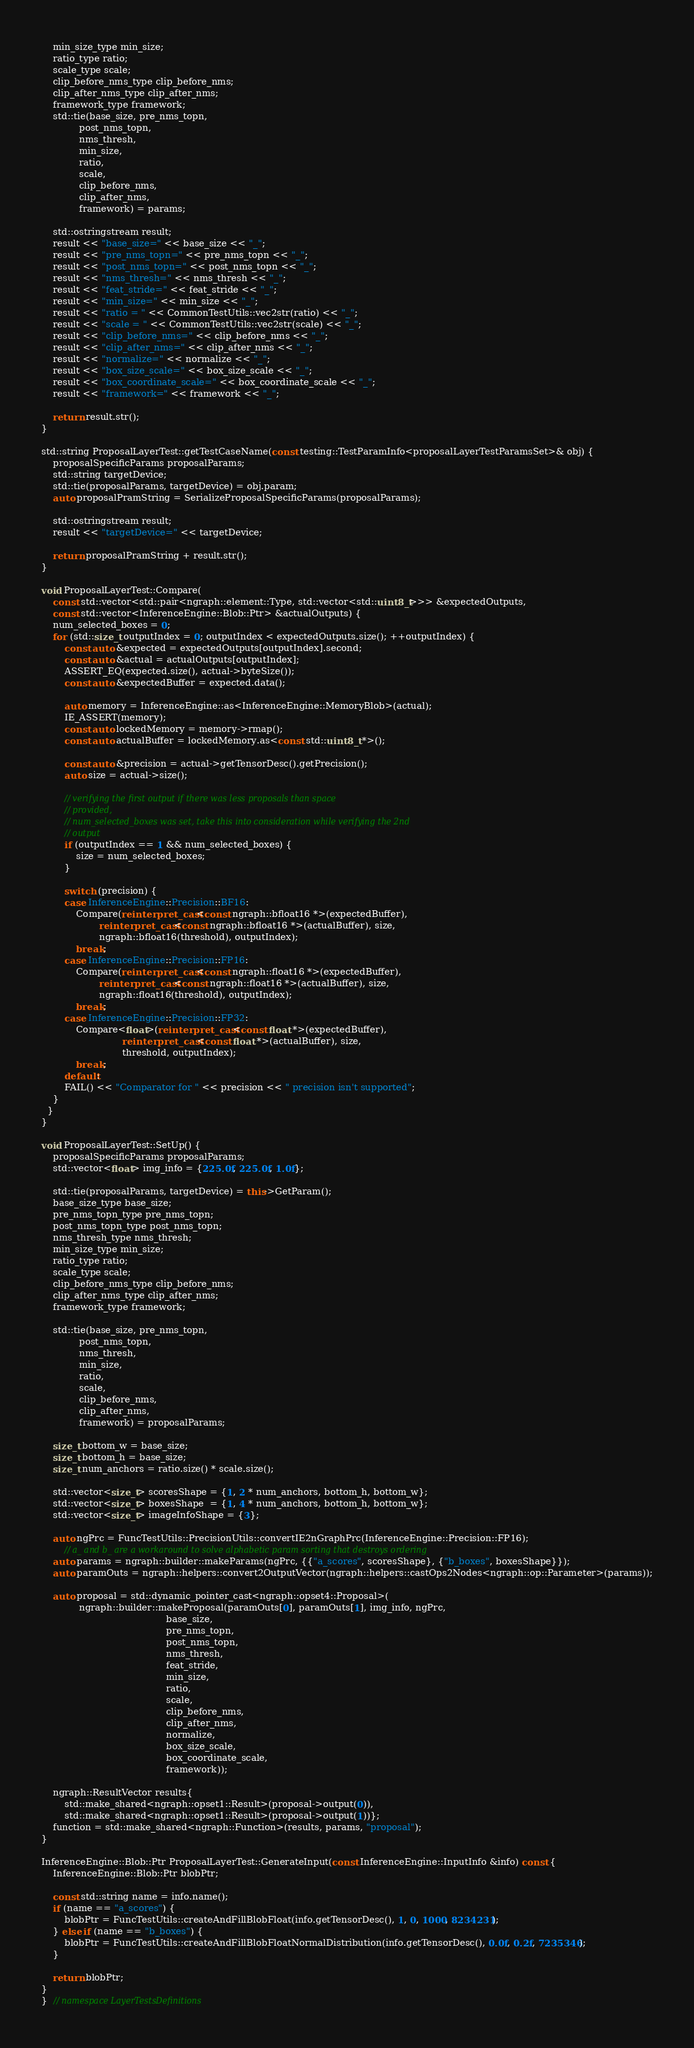Convert code to text. <code><loc_0><loc_0><loc_500><loc_500><_C++_>    min_size_type min_size;
    ratio_type ratio;
    scale_type scale;
    clip_before_nms_type clip_before_nms;
    clip_after_nms_type clip_after_nms;
    framework_type framework;
    std::tie(base_size, pre_nms_topn,
             post_nms_topn,
             nms_thresh,
             min_size,
             ratio,
             scale,
             clip_before_nms,
             clip_after_nms,
             framework) = params;

    std::ostringstream result;
    result << "base_size=" << base_size << "_";
    result << "pre_nms_topn=" << pre_nms_topn << "_";
    result << "post_nms_topn=" << post_nms_topn << "_";
    result << "nms_thresh=" << nms_thresh << "_";
    result << "feat_stride=" << feat_stride << "_";
    result << "min_size=" << min_size << "_";
    result << "ratio = " << CommonTestUtils::vec2str(ratio) << "_";
    result << "scale = " << CommonTestUtils::vec2str(scale) << "_";
    result << "clip_before_nms=" << clip_before_nms << "_";
    result << "clip_after_nms=" << clip_after_nms << "_";
    result << "normalize=" << normalize << "_";
    result << "box_size_scale=" << box_size_scale << "_";
    result << "box_coordinate_scale=" << box_coordinate_scale << "_";
    result << "framework=" << framework << "_";

    return result.str();
}

std::string ProposalLayerTest::getTestCaseName(const testing::TestParamInfo<proposalLayerTestParamsSet>& obj) {
    proposalSpecificParams proposalParams;
    std::string targetDevice;
    std::tie(proposalParams, targetDevice) = obj.param;
    auto proposalPramString = SerializeProposalSpecificParams(proposalParams);

    std::ostringstream result;
    result << "targetDevice=" << targetDevice;

    return proposalPramString + result.str();
}

void ProposalLayerTest::Compare(
    const std::vector<std::pair<ngraph::element::Type, std::vector<std::uint8_t>>> &expectedOutputs,
    const std::vector<InferenceEngine::Blob::Ptr> &actualOutputs) {
    num_selected_boxes = 0;
    for (std::size_t outputIndex = 0; outputIndex < expectedOutputs.size(); ++outputIndex) {
        const auto &expected = expectedOutputs[outputIndex].second;
        const auto &actual = actualOutputs[outputIndex];
        ASSERT_EQ(expected.size(), actual->byteSize());
        const auto &expectedBuffer = expected.data();

        auto memory = InferenceEngine::as<InferenceEngine::MemoryBlob>(actual);
        IE_ASSERT(memory);
        const auto lockedMemory = memory->rmap();
        const auto actualBuffer = lockedMemory.as<const std::uint8_t *>();

        const auto &precision = actual->getTensorDesc().getPrecision();
        auto size = actual->size();

        // verifying the first output if there was less proposals than space
        // provided,
        // num_selected_boxes was set, take this into consideration while verifying the 2nd
        // output
        if (outputIndex == 1 && num_selected_boxes) {
            size = num_selected_boxes;
        }

        switch (precision) {
        case InferenceEngine::Precision::BF16:
            Compare(reinterpret_cast<const ngraph::bfloat16 *>(expectedBuffer),
                    reinterpret_cast<const ngraph::bfloat16 *>(actualBuffer), size,
                    ngraph::bfloat16(threshold), outputIndex);
            break;
        case InferenceEngine::Precision::FP16:
            Compare(reinterpret_cast<const ngraph::float16 *>(expectedBuffer),
                    reinterpret_cast<const ngraph::float16 *>(actualBuffer), size,
                    ngraph::float16(threshold), outputIndex);
            break;
        case InferenceEngine::Precision::FP32:
            Compare<float>(reinterpret_cast<const float *>(expectedBuffer),
                            reinterpret_cast<const float *>(actualBuffer), size,
                            threshold, outputIndex);
            break;
        default:
        FAIL() << "Comparator for " << precision << " precision isn't supported";
    }
  }
}

void ProposalLayerTest::SetUp() {
    proposalSpecificParams proposalParams;
    std::vector<float> img_info = {225.0f, 225.0f, 1.0f};

    std::tie(proposalParams, targetDevice) = this->GetParam();
    base_size_type base_size;
    pre_nms_topn_type pre_nms_topn;
    post_nms_topn_type post_nms_topn;
    nms_thresh_type nms_thresh;
    min_size_type min_size;
    ratio_type ratio;
    scale_type scale;
    clip_before_nms_type clip_before_nms;
    clip_after_nms_type clip_after_nms;
    framework_type framework;

    std::tie(base_size, pre_nms_topn,
             post_nms_topn,
             nms_thresh,
             min_size,
             ratio,
             scale,
             clip_before_nms,
             clip_after_nms,
             framework) = proposalParams;

    size_t bottom_w = base_size;
    size_t bottom_h = base_size;
    size_t num_anchors = ratio.size() * scale.size();

    std::vector<size_t> scoresShape = {1, 2 * num_anchors, bottom_h, bottom_w};
    std::vector<size_t> boxesShape  = {1, 4 * num_anchors, bottom_h, bottom_w};
    std::vector<size_t> imageInfoShape = {3};

    auto ngPrc = FuncTestUtils::PrecisionUtils::convertIE2nGraphPrc(InferenceEngine::Precision::FP16);
        // a_ and b_ are a workaround to solve alphabetic param sorting that destroys ordering
    auto params = ngraph::builder::makeParams(ngPrc, {{"a_scores", scoresShape}, {"b_boxes", boxesShape}});
    auto paramOuts = ngraph::helpers::convert2OutputVector(ngraph::helpers::castOps2Nodes<ngraph::op::Parameter>(params));

    auto proposal = std::dynamic_pointer_cast<ngraph::opset4::Proposal>(
             ngraph::builder::makeProposal(paramOuts[0], paramOuts[1], img_info, ngPrc,
                                           base_size,
                                           pre_nms_topn,
                                           post_nms_topn,
                                           nms_thresh,
                                           feat_stride,
                                           min_size,
                                           ratio,
                                           scale,
                                           clip_before_nms,
                                           clip_after_nms,
                                           normalize,
                                           box_size_scale,
                                           box_coordinate_scale,
                                           framework));

    ngraph::ResultVector results{
        std::make_shared<ngraph::opset1::Result>(proposal->output(0)),
        std::make_shared<ngraph::opset1::Result>(proposal->output(1))};
    function = std::make_shared<ngraph::Function>(results, params, "proposal");
}

InferenceEngine::Blob::Ptr ProposalLayerTest::GenerateInput(const InferenceEngine::InputInfo &info) const {
    InferenceEngine::Blob::Ptr blobPtr;

    const std::string name = info.name();
    if (name == "a_scores") {
        blobPtr = FuncTestUtils::createAndFillBlobFloat(info.getTensorDesc(), 1, 0, 1000, 8234231);
    } else if (name == "b_boxes") {
        blobPtr = FuncTestUtils::createAndFillBlobFloatNormalDistribution(info.getTensorDesc(), 0.0f, 0.2f, 7235346);
    }

    return blobPtr;
}
}  // namespace LayerTestsDefinitions
</code> 